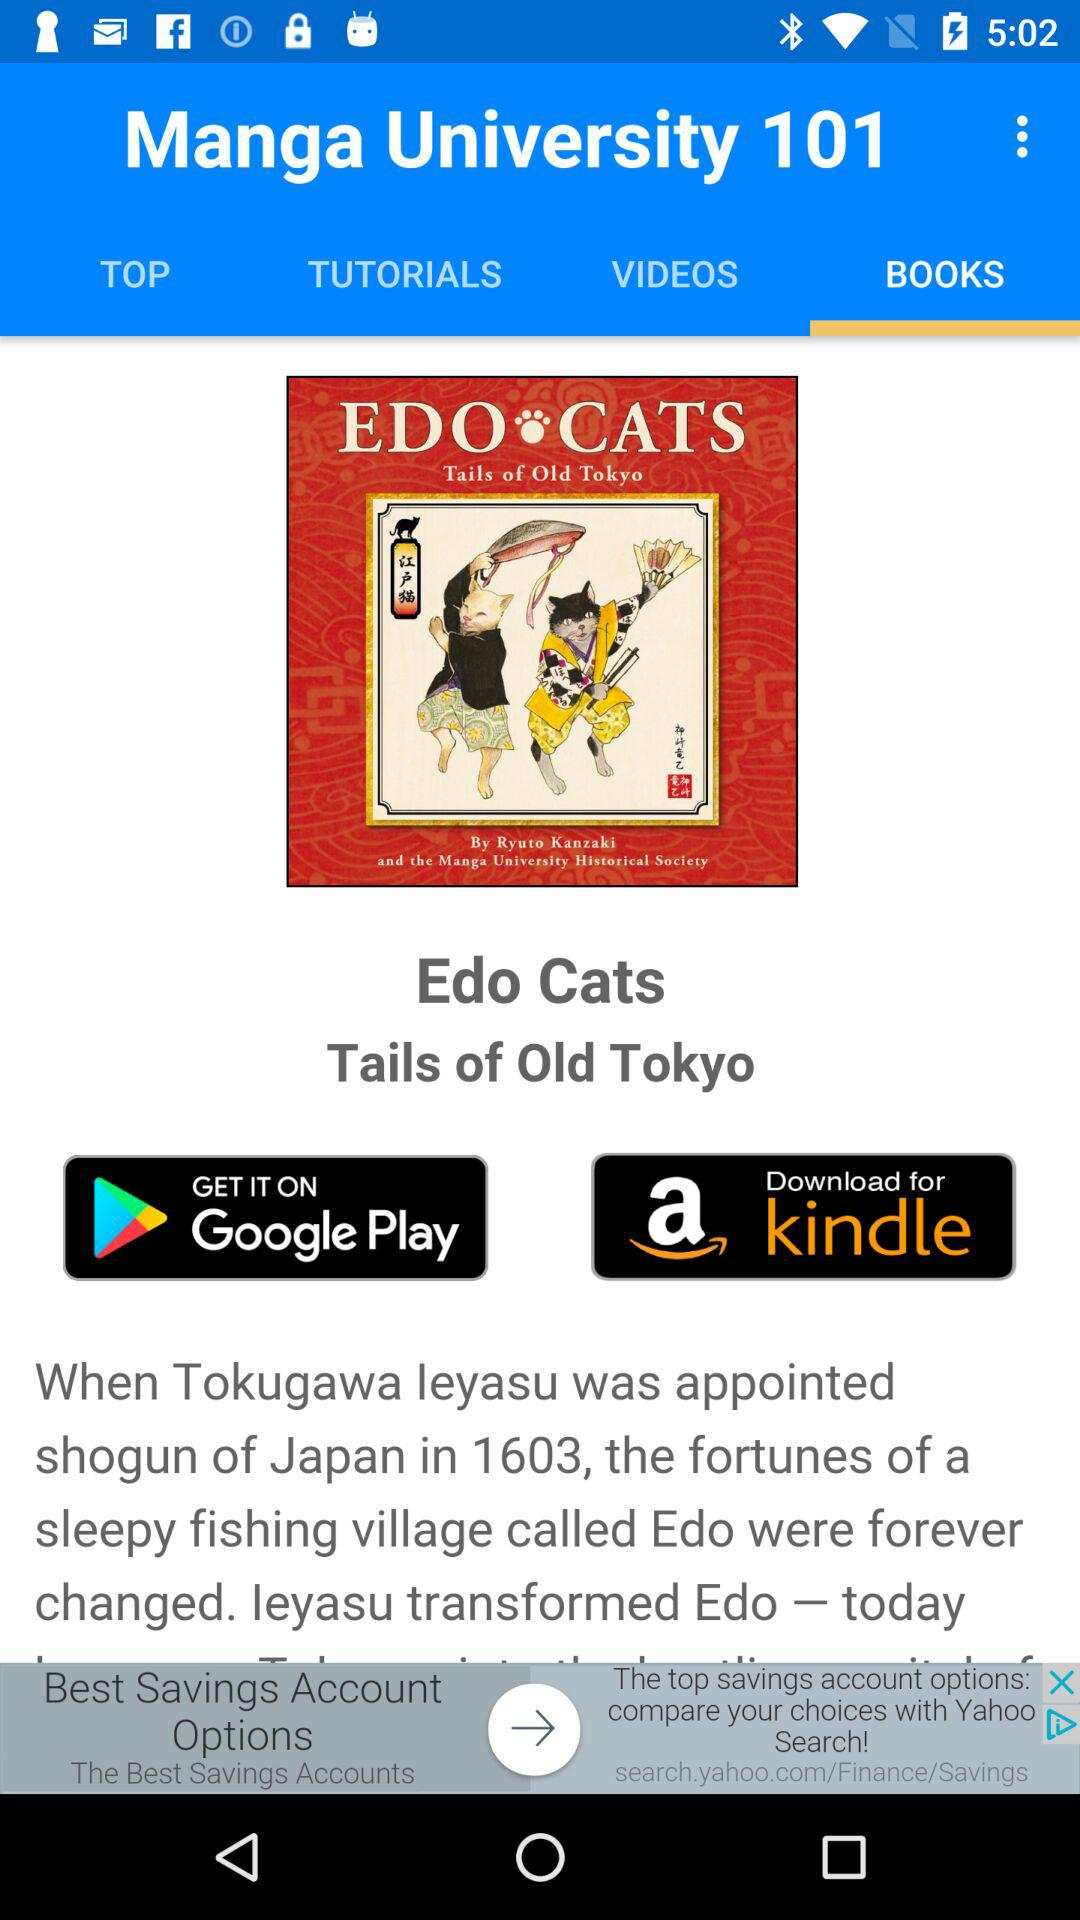What is the "Edo Cats" book about? It is about "Tails of Old Tokyo". 